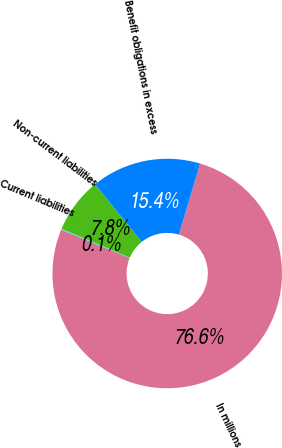Convert chart. <chart><loc_0><loc_0><loc_500><loc_500><pie_chart><fcel>In millions<fcel>Current liabilities<fcel>Non-current liabilities<fcel>Benefit obligations in excess<nl><fcel>76.61%<fcel>0.15%<fcel>7.8%<fcel>15.44%<nl></chart> 